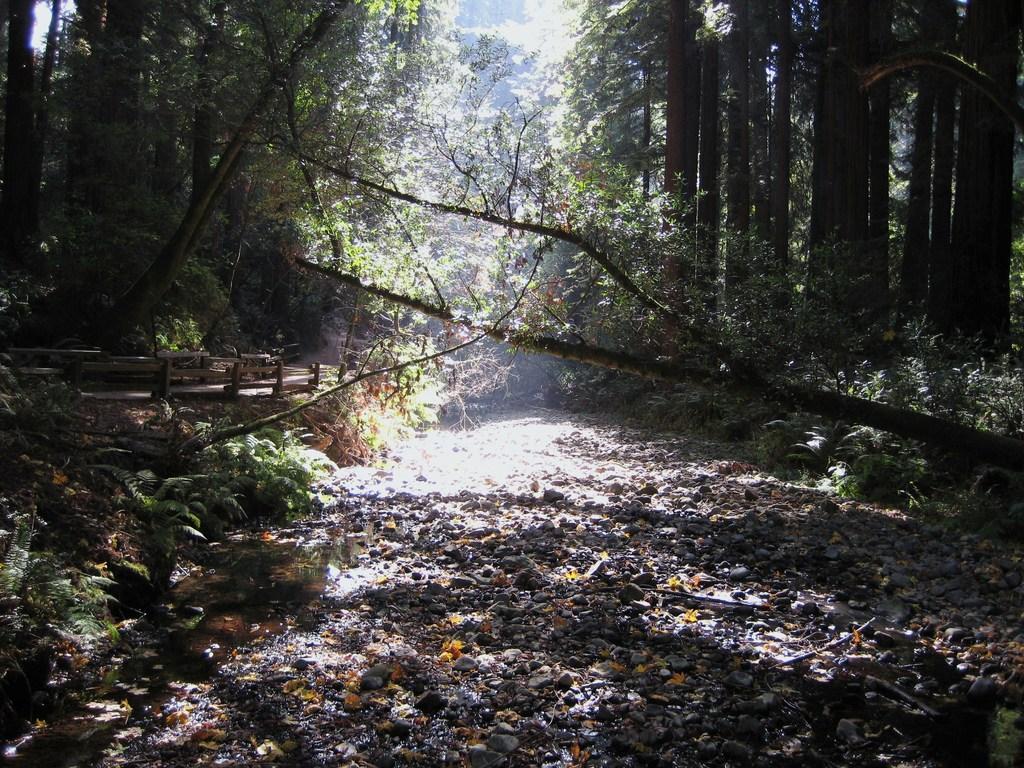Could you give a brief overview of what you see in this image? In this picture we can see plants and few stones on the ground and in the background we can see trees. 